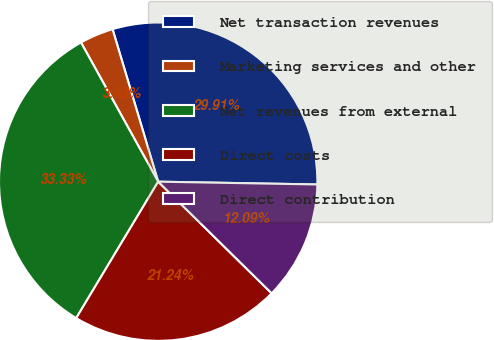Convert chart to OTSL. <chart><loc_0><loc_0><loc_500><loc_500><pie_chart><fcel>Net transaction revenues<fcel>Marketing services and other<fcel>Net revenues from external<fcel>Direct costs<fcel>Direct contribution<nl><fcel>29.91%<fcel>3.43%<fcel>33.33%<fcel>21.24%<fcel>12.09%<nl></chart> 